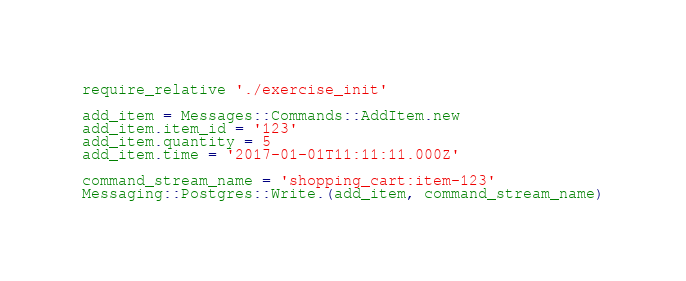<code> <loc_0><loc_0><loc_500><loc_500><_Ruby_>require_relative './exercise_init'

add_item = Messages::Commands::AddItem.new
add_item.item_id = '123'
add_item.quantity = 5
add_item.time = '2017-01-01T11:11:11.000Z'

command_stream_name = 'shopping_cart:item-123'
Messaging::Postgres::Write.(add_item, command_stream_name)
</code> 